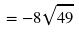<formula> <loc_0><loc_0><loc_500><loc_500>= - 8 \sqrt { 4 9 }</formula> 